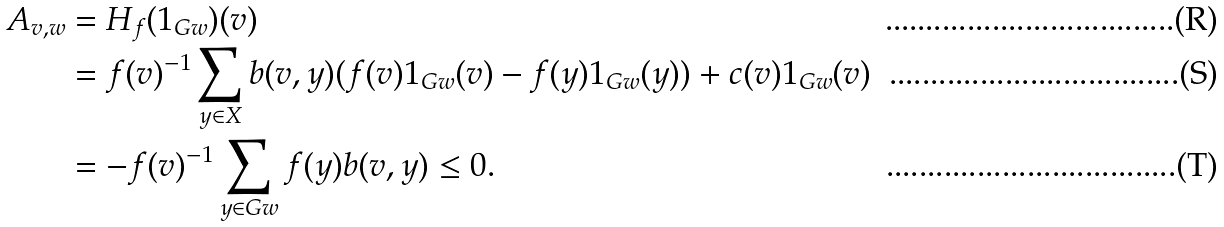Convert formula to latex. <formula><loc_0><loc_0><loc_500><loc_500>A _ { v , w } & = H _ { f } ( 1 _ { G w } ) ( v ) \\ & = f ( v ) ^ { - 1 } \sum _ { y \in X } b ( v , y ) ( f ( v ) 1 _ { G w } ( v ) - f ( y ) 1 _ { G w } ( y ) ) + c ( v ) 1 _ { G w } ( v ) \\ & = - f ( v ) ^ { - 1 } \sum _ { y \in G w } f ( y ) b ( v , y ) \leq 0 .</formula> 